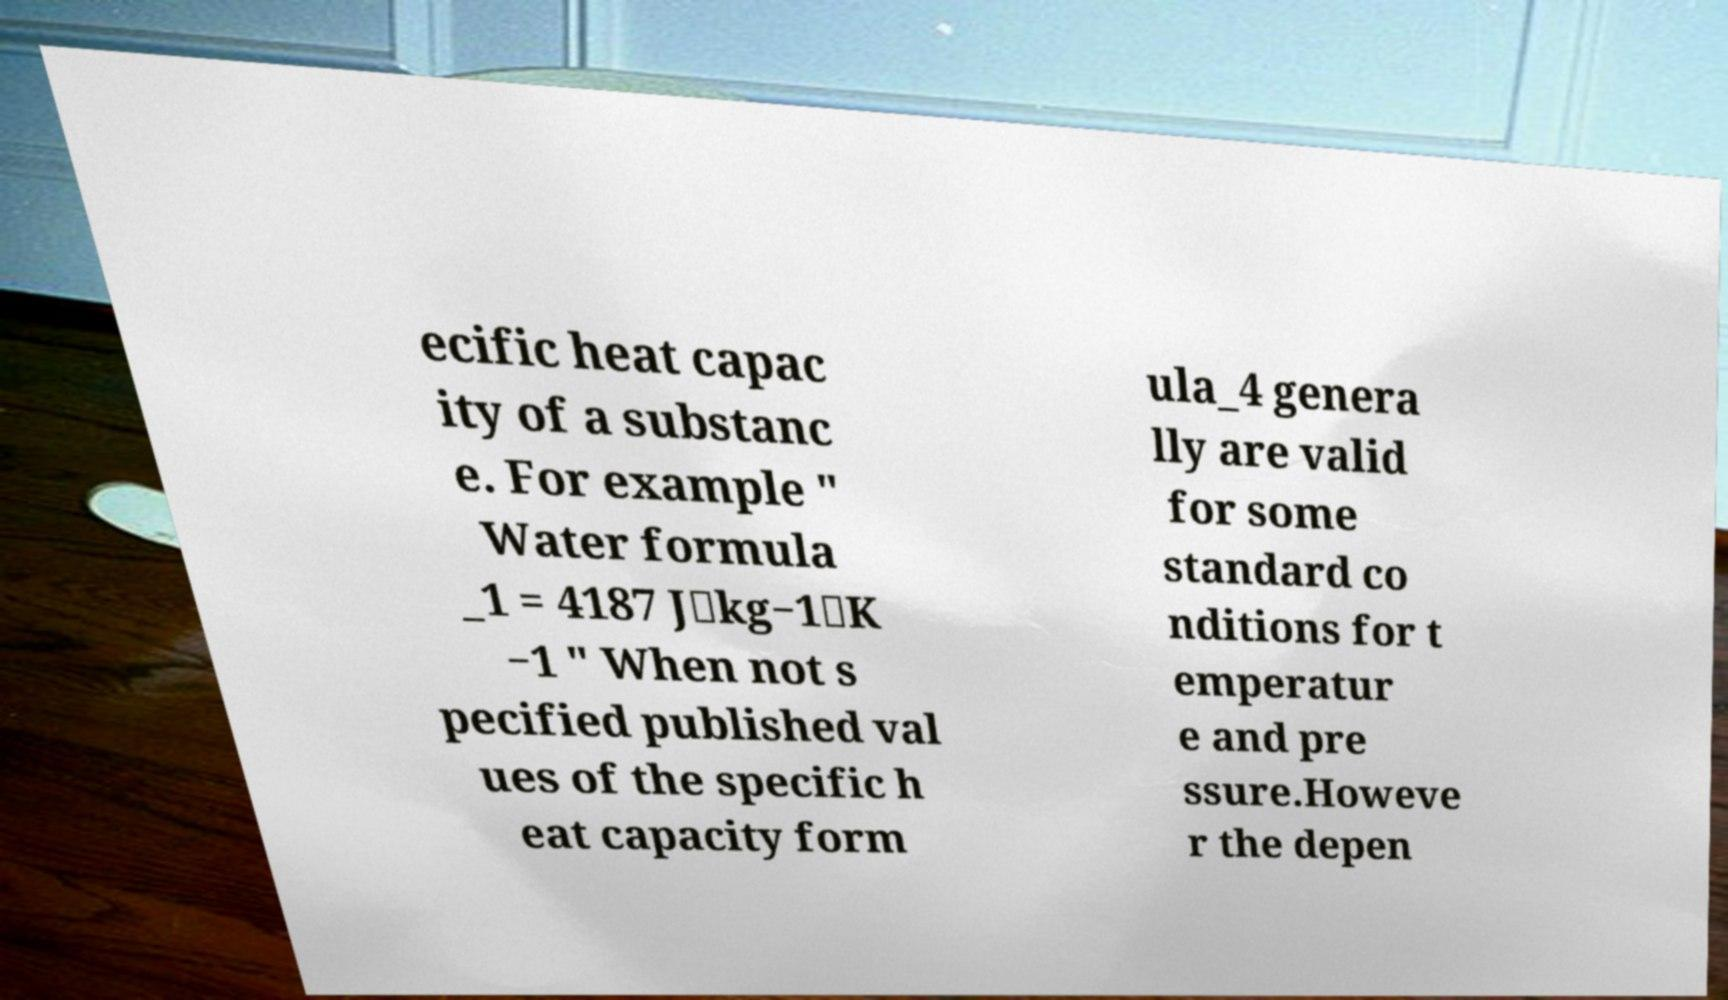What messages or text are displayed in this image? I need them in a readable, typed format. ecific heat capac ity of a substanc e. For example " Water formula _1 = 4187 J⋅kg−1⋅K −1 " When not s pecified published val ues of the specific h eat capacity form ula_4 genera lly are valid for some standard co nditions for t emperatur e and pre ssure.Howeve r the depen 